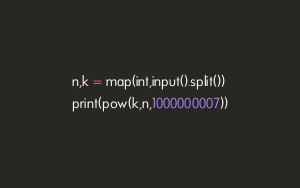Convert code to text. <code><loc_0><loc_0><loc_500><loc_500><_Python_>n,k = map(int,input().split())
print(pow(k,n,1000000007))
</code> 